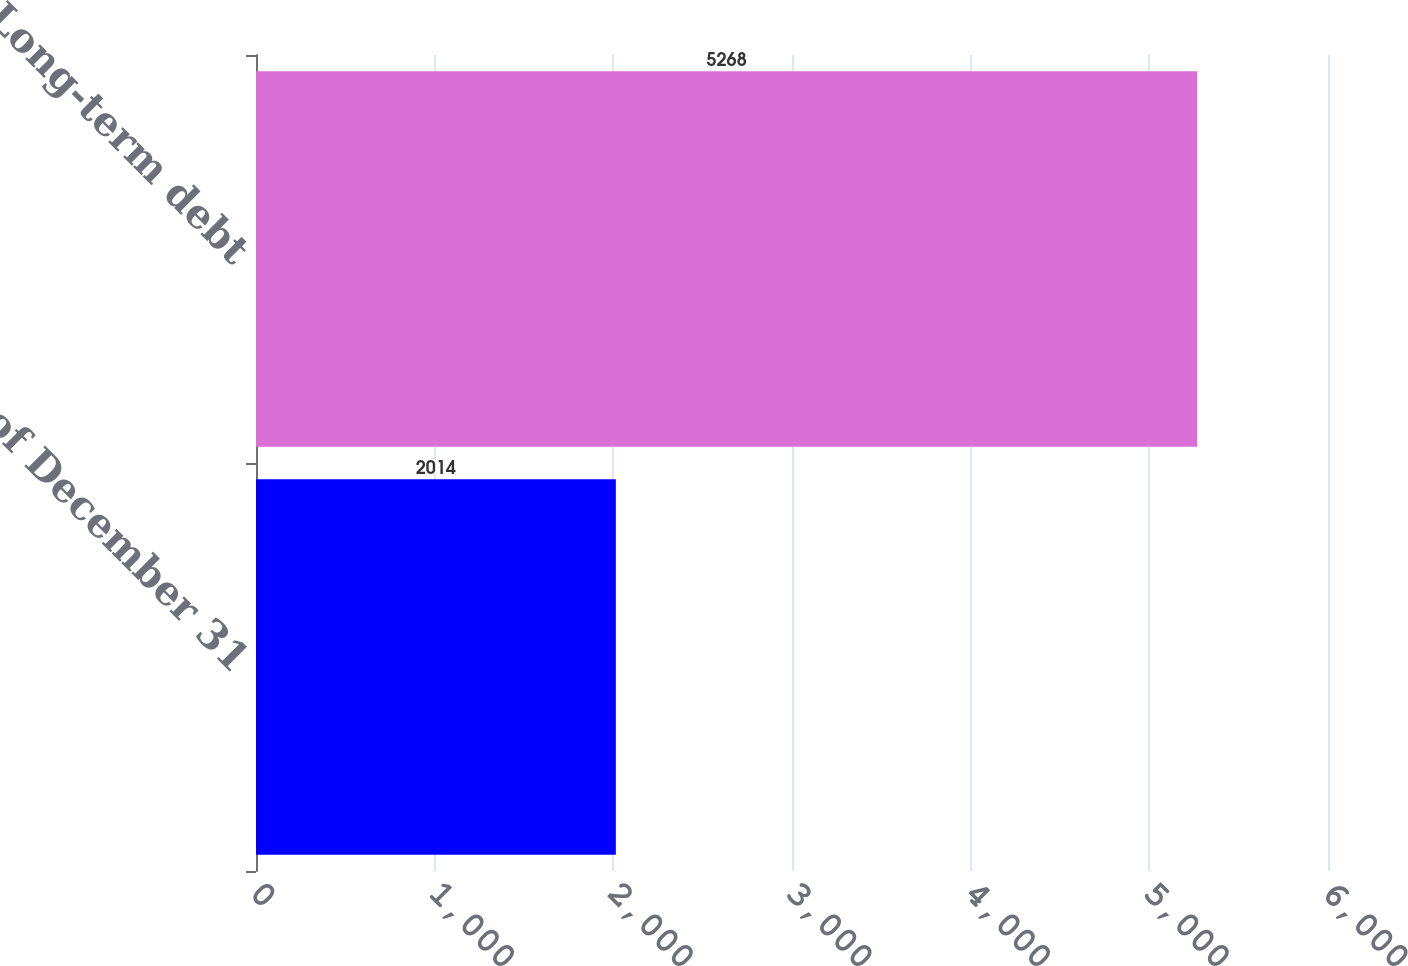Convert chart. <chart><loc_0><loc_0><loc_500><loc_500><bar_chart><fcel>As of December 31<fcel>Long-term debt<nl><fcel>2014<fcel>5268<nl></chart> 